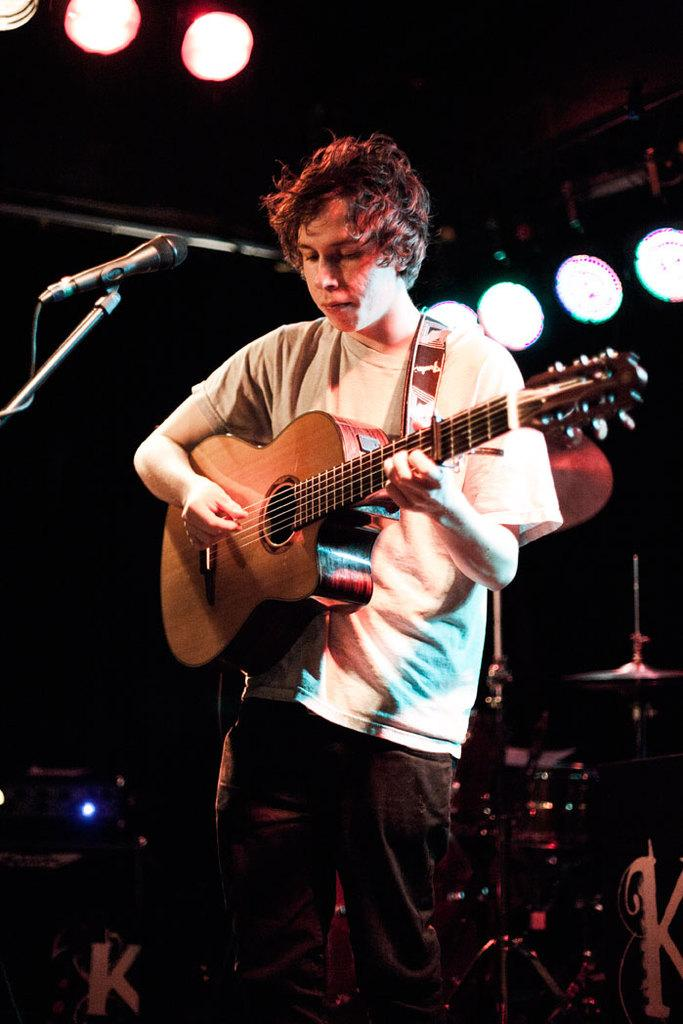Who is the main subject in the image? There is a man in the image. What is the man doing in the image? The man is standing in front of a microphone and playing a guitar. What else can be seen in the image besides the man and his instruments? There are lights visible in the image. What type of mark can be seen on the man's tongue in the image? There is no mark visible on the man's tongue in the image, as his tongue is not shown. What can the man do with the can in the image? There is no can present in the image, so it is not possible to determine what the man might do with it. 